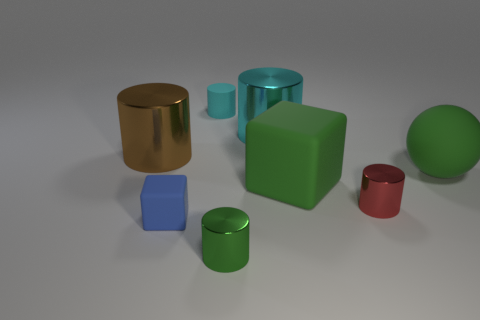How many objects are metallic things or cylinders that are to the right of the large brown metallic object? 5 